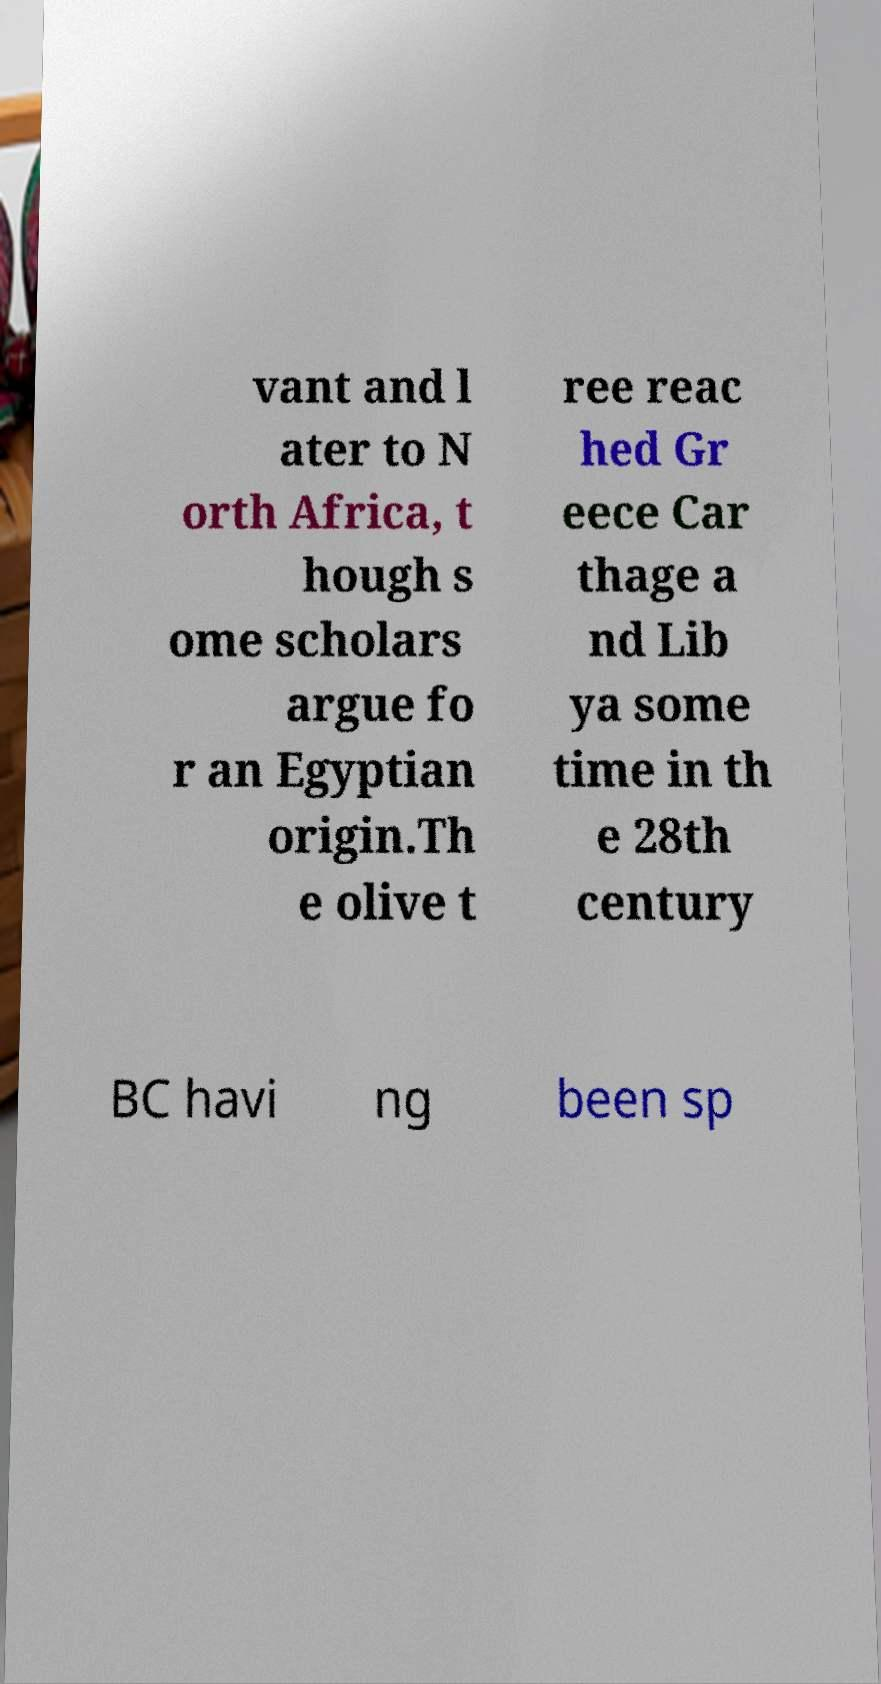There's text embedded in this image that I need extracted. Can you transcribe it verbatim? vant and l ater to N orth Africa, t hough s ome scholars argue fo r an Egyptian origin.Th e olive t ree reac hed Gr eece Car thage a nd Lib ya some time in th e 28th century BC havi ng been sp 